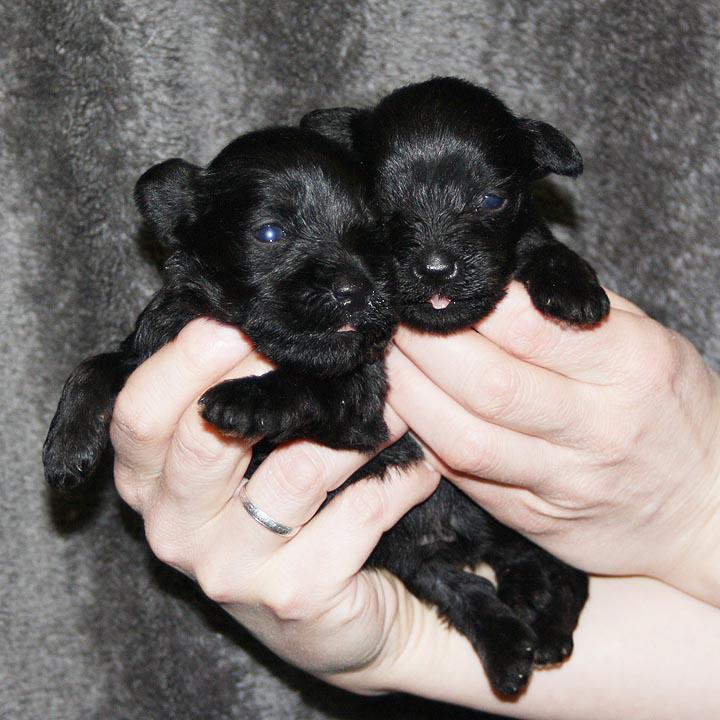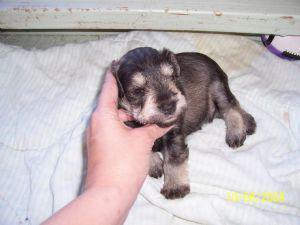The first image is the image on the left, the second image is the image on the right. Examine the images to the left and right. Is the description "A human is holding the puppy in the image on the right." accurate? Answer yes or no. Yes. The first image is the image on the left, the second image is the image on the right. Given the left and right images, does the statement "There is a single puppy being held in the air in one image." hold true? Answer yes or no. No. 